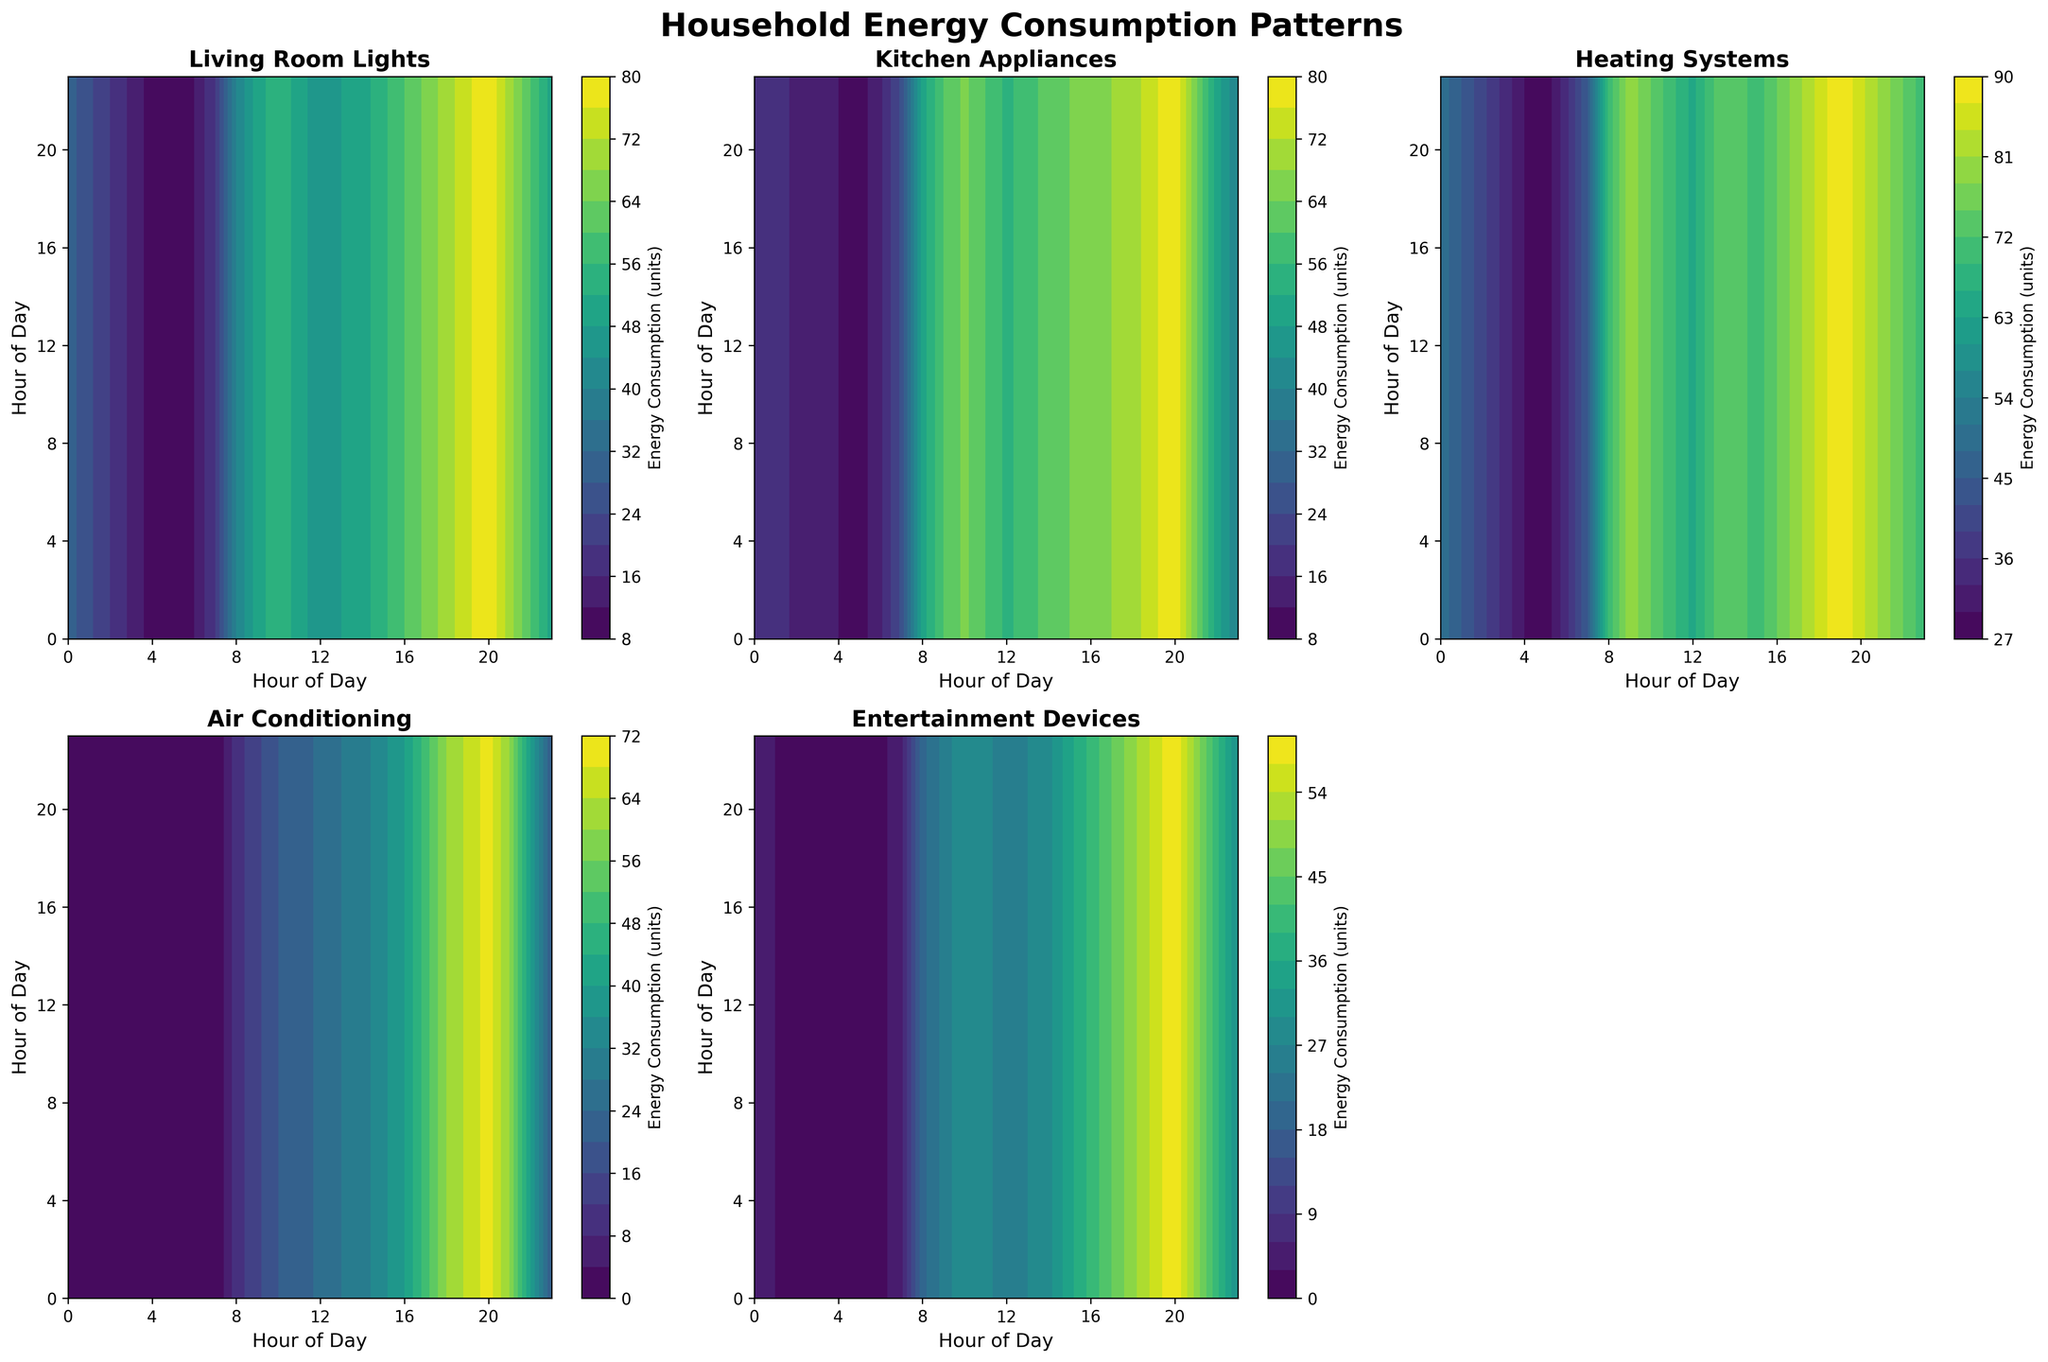What is the title of the figure? The title of the figure can be found at the top, where it is usually prominently displayed. It reads, "Household Energy Consumption Patterns."
Answer: Household Energy Consumption Patterns Which appliance has the highest energy consumption at 19:00? To answer this, locate the subplot for each appliance and find the 19:00 mark on the x-axis (Hour of Day). Then compare the energy consumption levels at that point. The subplot for "Living Room Lights" shows the highest energy consumption at that hour.
Answer: Living Room Lights How does the energy consumption of Kitchen Appliances change from 08:00 to 20:00? Focus on the subplot for "Kitchen Appliances" and trace the energy levels from 08:00 to 20:00 on the x-axis. The consumption rapidly increases from 40 units at 08:00 to peak at 80 units around 09:00 to 11:00, and then shows a gradual decrease.
Answer: Increases rapidly, peaks, then gradually decreases What is the median energy consumption of Air Conditioning based on the contour plot? Observe the contour plot for Air Conditioning. The color gradients correspond to different energy consumption levels. To estimate the median, look at the distribution of colors or contour lines and identify the middle value. The approximate median energy consumption appears around 30 units.
Answer: Around 30 units Compare the energy consumption of Living Room Lights and Entertainment Devices at 22:00. Which one is higher and by how much? Locate the 22:00 mark on the x-axis for both Living Room Lights and Entertainment Devices subplots, then note the energy consumption values. Living Room Lights has a consumption of 60 units, while Entertainment Devices have 40 units. Living Room Lights' consumption is higher by 20 units.
Answer: Living Room Lights, by 20 units During which hour is the energy consumption for Heating Systems highest? Find the subplot for Heating Systems and observe the contour lines or color gradients across different hours on the x-axis. The highest energy consumption is at 19:00.
Answer: 19:00 What pattern do you observe for Air Conditioning energy consumption throughout the day? Examine the contour plot for Air Conditioning, looking at how the color changes across hours. The energy consumption is zero during early hours, starts to rise after 08:00, then peaks between 18:00 and 20:00.
Answer: Zero early, rises after 08:00, peaks 18:00-20:00 Which appliance shows a steady increase in energy consumption until mid-day and then a gradual decline? Look at each subplot and find the one where energy consumption increases steadily until around mid-day (12:00), then gradually falls. Kitchen Appliances show this trend.
Answer: Kitchen Appliances What is the primary color gradient used in the plots? Review the color scheme used in the contour plots, which helps to visually interpret energy consumption levels. The primary gradient used is viridis, which goes from purple (low) to yellow (high).
Answer: Viridis (purple to yellow) Summarize the energy consumption patterns for Entertainment Devices across the day. Observe the contour plot for Entertainment Devices, noting color changes or contour lines throughout the hours. The usage is minimal early in the day, begins to increase around 08:00, peaks at around 20:00, and then starts declining after 21:00.
Answer: Minimal early, increases after 08:00, peaks at 20:00, declines after 21:00 